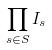Convert formula to latex. <formula><loc_0><loc_0><loc_500><loc_500>\prod _ { s \in S } I _ { s }</formula> 